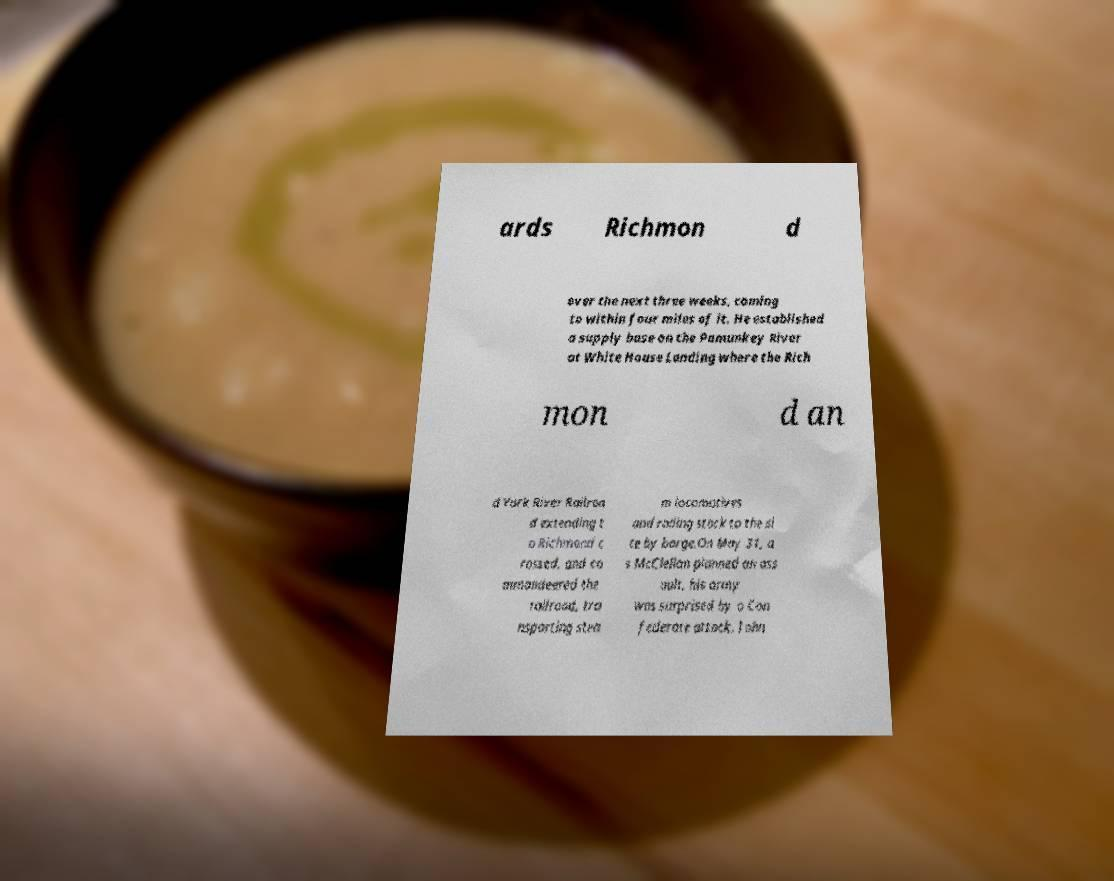What messages or text are displayed in this image? I need them in a readable, typed format. ards Richmon d over the next three weeks, coming to within four miles of it. He established a supply base on the Pamunkey River at White House Landing where the Rich mon d an d York River Railroa d extending t o Richmond c rossed, and co mmandeered the railroad, tra nsporting stea m locomotives and rolling stock to the si te by barge.On May 31, a s McClellan planned an ass ault, his army was surprised by a Con federate attack. John 